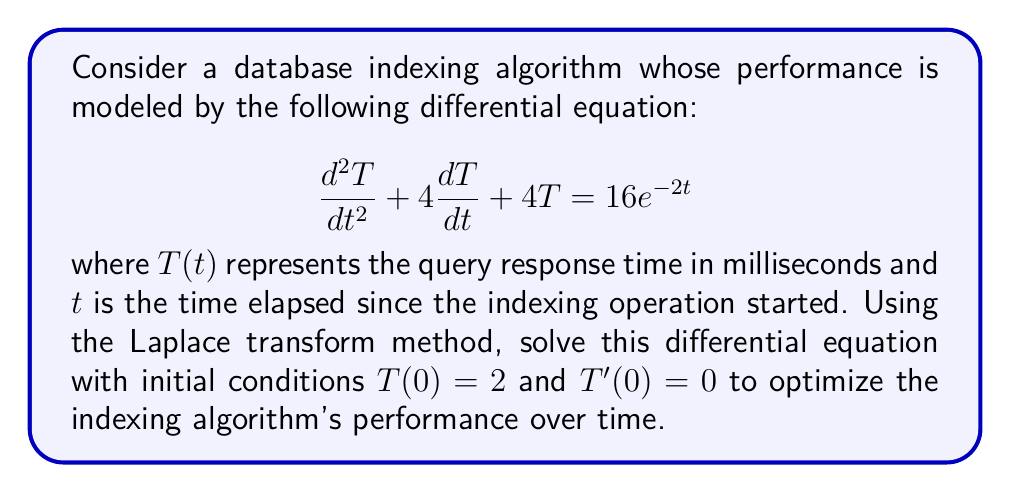Show me your answer to this math problem. To solve this differential equation using the Laplace transform method, we'll follow these steps:

1) Take the Laplace transform of both sides of the equation:
   $$\mathcal{L}\{T''(t) + 4T'(t) + 4T(t)\} = \mathcal{L}\{16e^{-2t}\}$$

2) Using Laplace transform properties:
   $$s^2\mathcal{L}\{T(t)\} - sT(0) - T'(0) + 4s\mathcal{L}\{T(t)\} - 4T(0) + 4\mathcal{L}\{T(t)\} = \frac{16}{s+2}$$

3) Let $\mathcal{L}\{T(t)\} = X(s)$. Substitute the initial conditions:
   $$s^2X(s) - 2s - 0 + 4sX(s) - 8 + 4X(s) = \frac{16}{s+2}$$

4) Simplify:
   $$(s^2 + 4s + 4)X(s) = \frac{16}{s+2} + 2s + 8$$

5) Solve for X(s):
   $$X(s) = \frac{16}{(s+2)^3} + \frac{2s + 8}{(s+2)^2}$$

6) Decompose into partial fractions:
   $$X(s) = \frac{16}{(s+2)^3} + \frac{2}{s+2} + \frac{2}{(s+2)^2}$$

7) Take the inverse Laplace transform:
   $$T(t) = \mathcal{L}^{-1}\{X(s)\} = 8t^2e^{-2t} + 2e^{-2t} + 2te^{-2t}$$

8) Simplify:
   $$T(t) = (8t^2 + 2t + 2)e^{-2t}$$

This solution represents the optimized query response time as a function of time since the indexing operation started.
Answer: $T(t) = (8t^2 + 2t + 2)e^{-2t}$ 